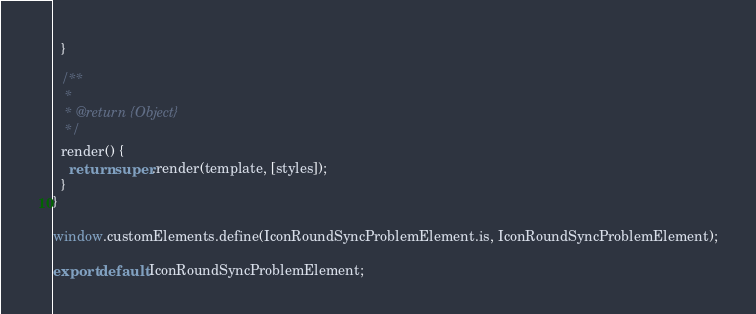<code> <loc_0><loc_0><loc_500><loc_500><_JavaScript_>  }

  /**
   *
   * @return {Object}
   */
  render() {
    return super.render(template, [styles]);
  }
}

window.customElements.define(IconRoundSyncProblemElement.is, IconRoundSyncProblemElement);

export default IconRoundSyncProblemElement;
</code> 